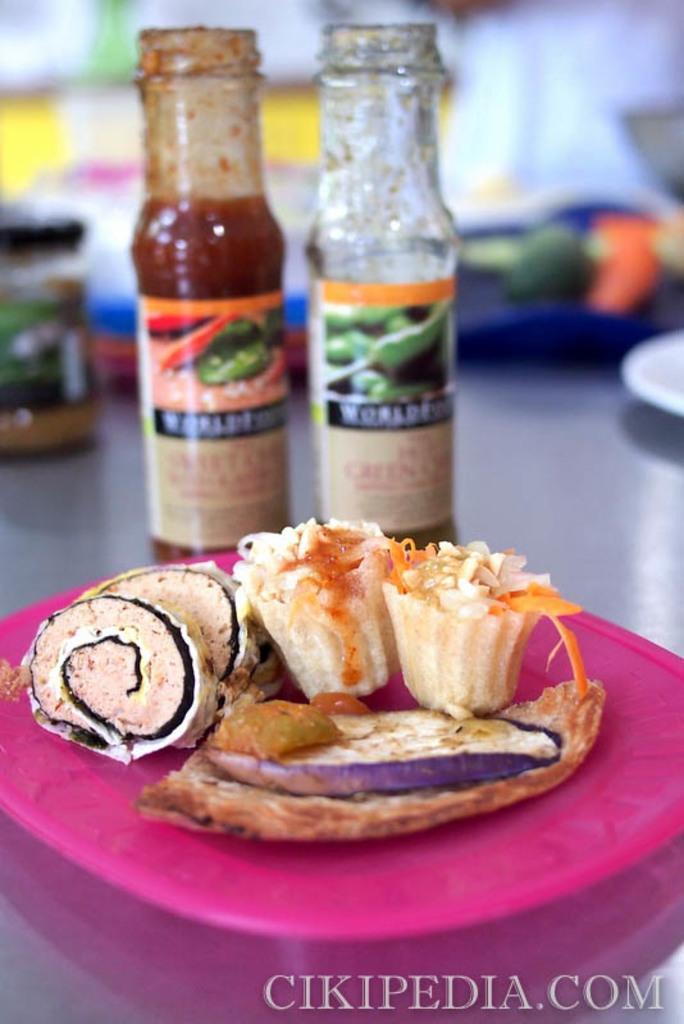Can you describe this image briefly? In this picture we can see a plate and two bottles in the front, there is some food present in this plate, there are stickers pasted on these bottles, these is a blurry background, at the right bottom there is some text. 